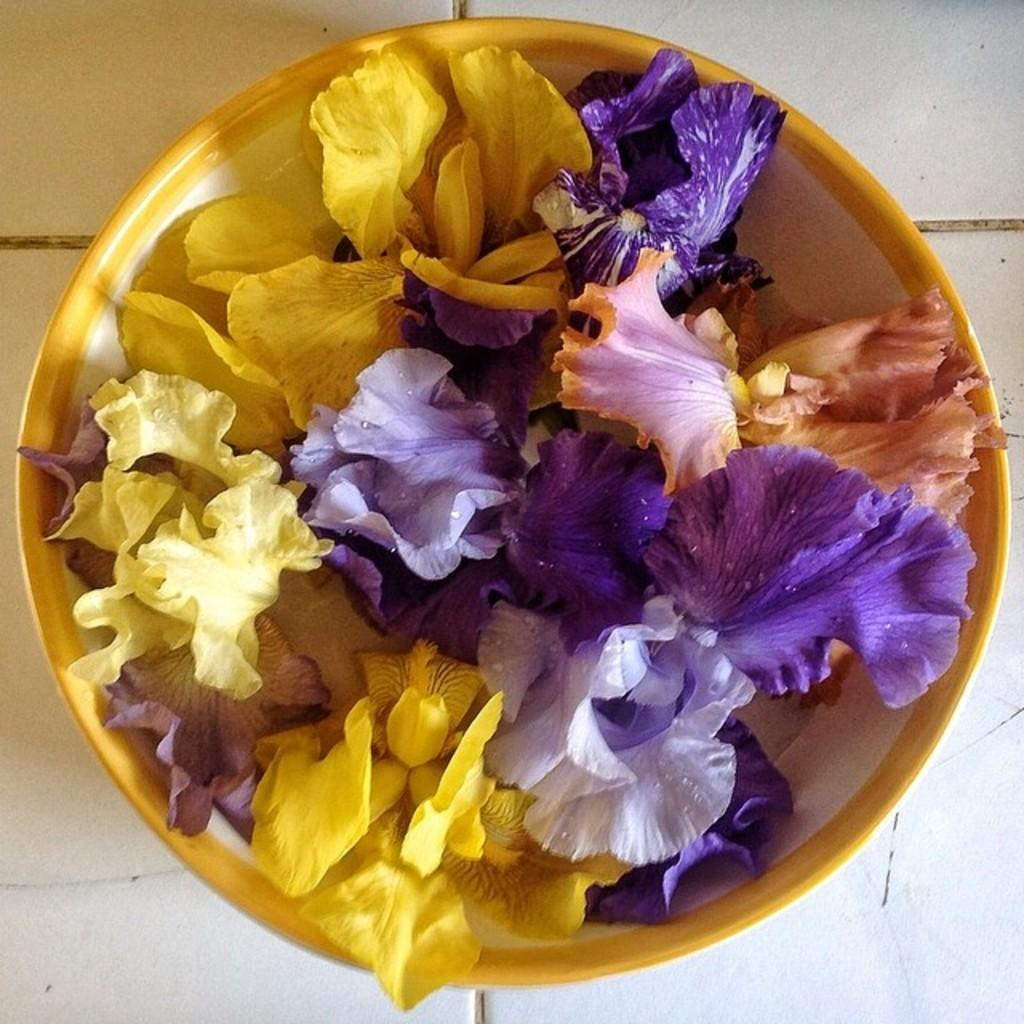What is in the bowl that is visible in the image? The bowl contains flowers. Where is the bowl located in the image? The bowl is placed on a table. What type of produce can be seen in the bowl? There is no produce present in the image; the bowl contains flowers. 